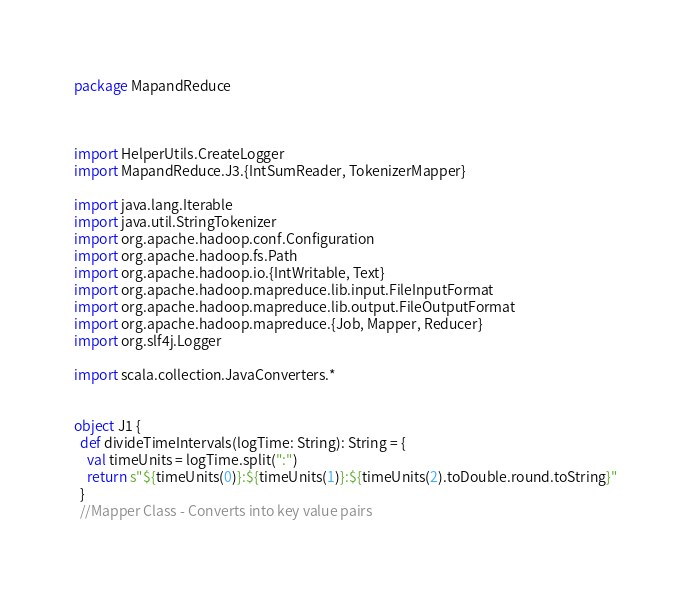Convert code to text. <code><loc_0><loc_0><loc_500><loc_500><_Scala_>package MapandReduce



import HelperUtils.CreateLogger
import MapandReduce.J3.{IntSumReader, TokenizerMapper}

import java.lang.Iterable
import java.util.StringTokenizer
import org.apache.hadoop.conf.Configuration
import org.apache.hadoop.fs.Path
import org.apache.hadoop.io.{IntWritable, Text}
import org.apache.hadoop.mapreduce.lib.input.FileInputFormat
import org.apache.hadoop.mapreduce.lib.output.FileOutputFormat
import org.apache.hadoop.mapreduce.{Job, Mapper, Reducer}
import org.slf4j.Logger

import scala.collection.JavaConverters.*


object J1 {
  def divideTimeIntervals(logTime: String): String = {
    val timeUnits = logTime.split(":")
    return s"${timeUnits(0)}:${timeUnits(1)}:${timeUnits(2).toDouble.round.toString}"
  }
  //Mapper Class - Converts into key value pairs</code> 